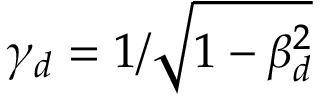<formula> <loc_0><loc_0><loc_500><loc_500>\gamma _ { d } = 1 / \sqrt { 1 - \beta _ { d } ^ { 2 } }</formula> 